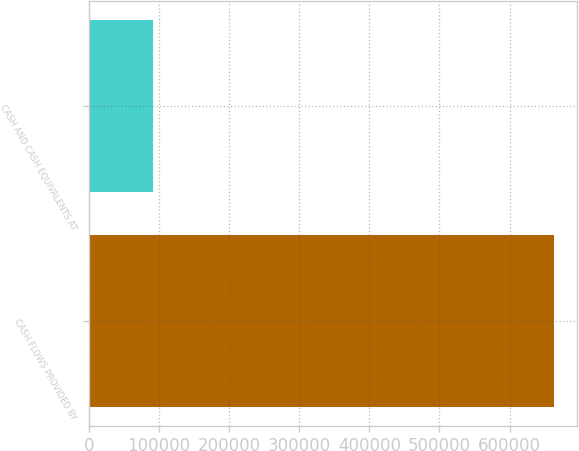Convert chart. <chart><loc_0><loc_0><loc_500><loc_500><bar_chart><fcel>CASH FLOWS PROVIDED BY<fcel>CASH AND CASH EQUIVALENTS AT<nl><fcel>663640<fcel>91244<nl></chart> 